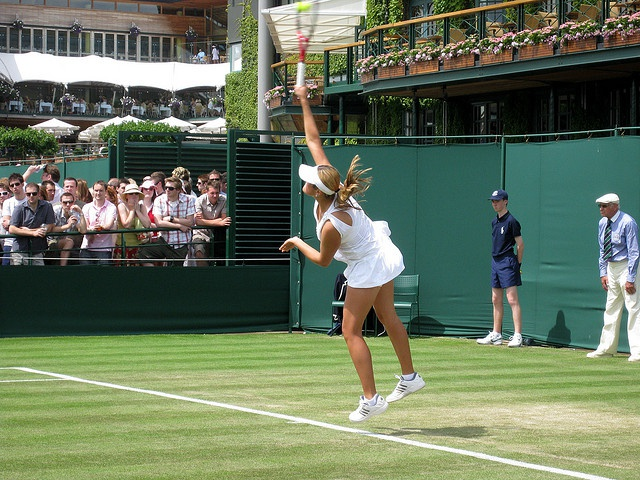Describe the objects in this image and their specific colors. I can see people in gray, lavender, maroon, brown, and darkgray tones, people in gray, white, and darkgray tones, people in gray, black, and white tones, people in gray, black, and navy tones, and people in gray, black, lightgray, and darkgray tones in this image. 